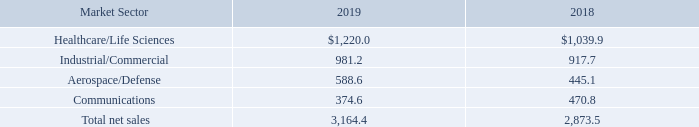Our net sales by market sector for the indicated fiscal years were as follows (in millions):
Healthcare/Life Sciences. Net sales for fiscal 2019 in the Healthcare/Life Sciences sector increased $180.1 million, or 17.3%, as compared to fiscal 2018. The increase was driven by overall net increased customer end-market demand, a $32.7 million increase in production ramps of new products for existing customers and a $26.9 million increase in production ramps for new customers.
Industrial/Commercial. Net sales for fiscal 2019 in the Industrial/Commercial sector increased $63.5 million, or 6.9%, as compared to fiscal 2018. The increase was driven by a $64.8 million increase in production ramps of new products for existing customers and a $33.2 million increase in production ramps for new customers. The increase was partially offset by a $7.3 million decrease due to end-of-life products, a $4.2 million decrease due to a disengagement with a customer and overall net decreased customer end-market demand.
Aerospace/Defense. Net sales for fiscal 2019 in the Aerospace/Defense sector increased $143.5 million, or 32.2%, as compared to fiscal 2018. The increase was driven by a $120.2 million increase in production ramps of new products for existing customers, a $9.9 million increase in production ramps for new customers and overall net increased customer end-market demand.
Communications. Net sales for fiscal 2019 in the Communications sector decreased $96.2 million, or 20.4%, as compared to fiscal 2018. The decrease was driven by a $37.3 million reduction due to disengagements with customers, a $15.3 million decrease due to end-of-life products and overall net decreased customer endmarket demand. The decrease was partially offset by an $18.1 million increase in production ramps of new products for existing customers and a $4.5 million increase in production ramps for new customers.
Which years does the table provide information for the company's net sales by market sector? 2019, 2018. What was the net sales in the healthcare/life sciences sector in 2019?
Answer scale should be: million. 1,220.0. What was the net sales in the aerospace/defense sector in 2018?
Answer scale should be: million. 445.1. Which years did the net sales from Communications exceed $400 million? (2018:445.1)
Answer: 2018. What was the difference in the net sales in 2019 between the industrial/commercial and communications sector?
Answer scale should be: million. 981.2-374.6
Answer: 606.6. What was the percentage change in the total net sales between 2018 and 2019?
Answer scale should be: percent. (3,164.4-2,873.5)/2,873.5
Answer: 10.12. 